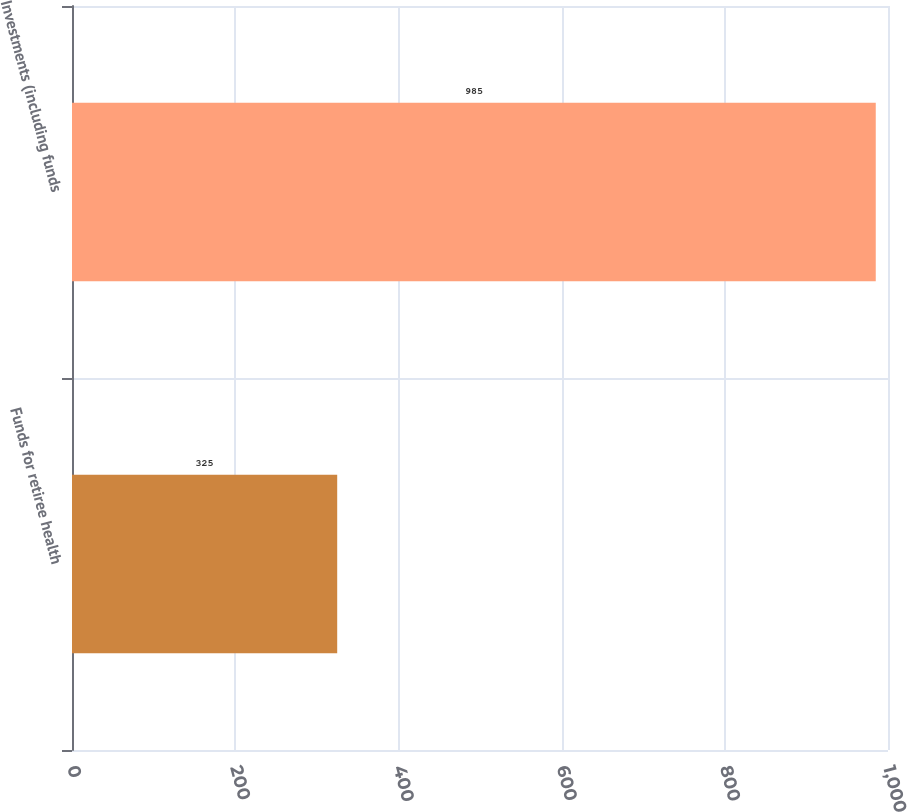Convert chart to OTSL. <chart><loc_0><loc_0><loc_500><loc_500><bar_chart><fcel>Funds for retiree health<fcel>Investments (including funds<nl><fcel>325<fcel>985<nl></chart> 